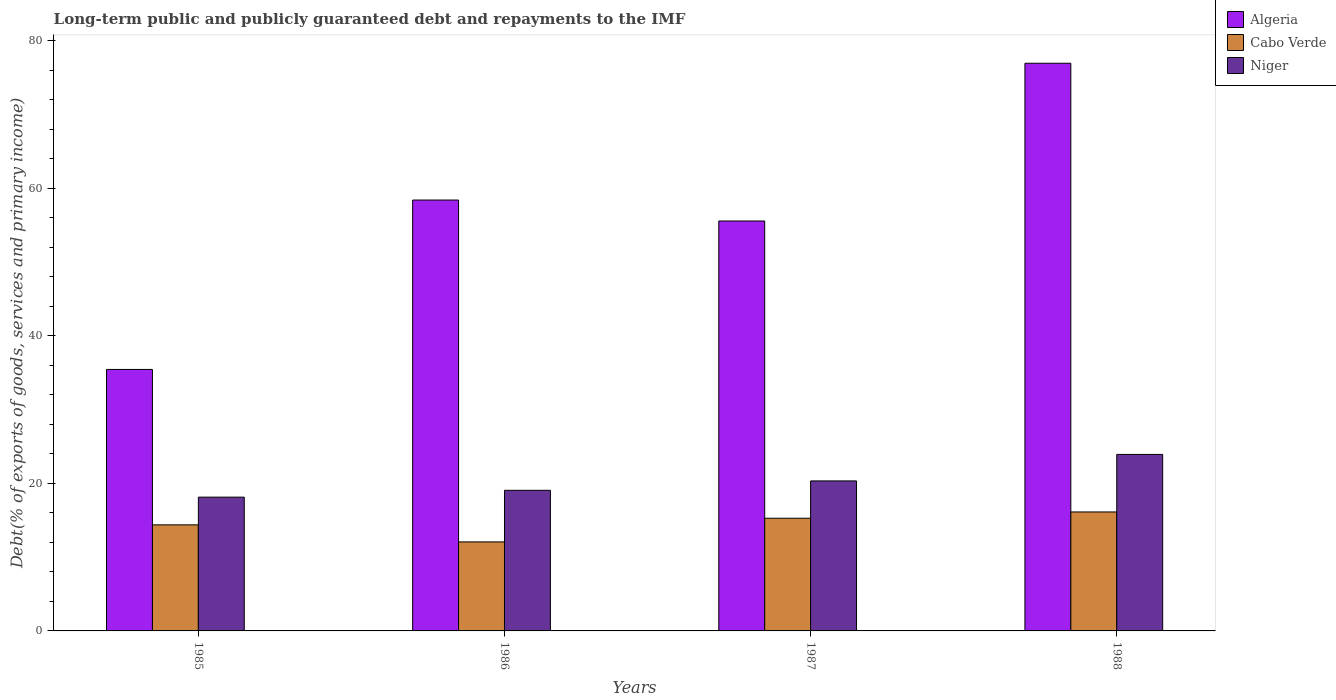Are the number of bars per tick equal to the number of legend labels?
Your answer should be very brief. Yes. Are the number of bars on each tick of the X-axis equal?
Offer a very short reply. Yes. What is the debt and repayments in Niger in 1986?
Ensure brevity in your answer.  19.05. Across all years, what is the maximum debt and repayments in Algeria?
Ensure brevity in your answer.  76.93. Across all years, what is the minimum debt and repayments in Algeria?
Your answer should be very brief. 35.43. In which year was the debt and repayments in Algeria maximum?
Your response must be concise. 1988. In which year was the debt and repayments in Cabo Verde minimum?
Provide a succinct answer. 1986. What is the total debt and repayments in Algeria in the graph?
Provide a succinct answer. 226.31. What is the difference between the debt and repayments in Niger in 1987 and that in 1988?
Your response must be concise. -3.59. What is the difference between the debt and repayments in Cabo Verde in 1986 and the debt and repayments in Niger in 1987?
Ensure brevity in your answer.  -8.27. What is the average debt and repayments in Algeria per year?
Offer a terse response. 56.58. In the year 1986, what is the difference between the debt and repayments in Cabo Verde and debt and repayments in Niger?
Your response must be concise. -6.99. In how many years, is the debt and repayments in Cabo Verde greater than 68 %?
Provide a short and direct response. 0. What is the ratio of the debt and repayments in Algeria in 1985 to that in 1986?
Your response must be concise. 0.61. Is the debt and repayments in Niger in 1986 less than that in 1987?
Ensure brevity in your answer.  Yes. Is the difference between the debt and repayments in Cabo Verde in 1986 and 1987 greater than the difference between the debt and repayments in Niger in 1986 and 1987?
Offer a terse response. No. What is the difference between the highest and the second highest debt and repayments in Niger?
Provide a succinct answer. 3.59. What is the difference between the highest and the lowest debt and repayments in Algeria?
Provide a succinct answer. 41.49. Is the sum of the debt and repayments in Algeria in 1985 and 1987 greater than the maximum debt and repayments in Cabo Verde across all years?
Your response must be concise. Yes. What does the 1st bar from the left in 1985 represents?
Give a very brief answer. Algeria. What does the 1st bar from the right in 1986 represents?
Provide a short and direct response. Niger. Are all the bars in the graph horizontal?
Ensure brevity in your answer.  No. Are the values on the major ticks of Y-axis written in scientific E-notation?
Provide a succinct answer. No. Does the graph contain grids?
Provide a succinct answer. No. How many legend labels are there?
Make the answer very short. 3. How are the legend labels stacked?
Ensure brevity in your answer.  Vertical. What is the title of the graph?
Make the answer very short. Long-term public and publicly guaranteed debt and repayments to the IMF. Does "Zambia" appear as one of the legend labels in the graph?
Provide a short and direct response. No. What is the label or title of the Y-axis?
Offer a terse response. Debt(% of exports of goods, services and primary income). What is the Debt(% of exports of goods, services and primary income) of Algeria in 1985?
Offer a very short reply. 35.43. What is the Debt(% of exports of goods, services and primary income) of Cabo Verde in 1985?
Offer a terse response. 14.37. What is the Debt(% of exports of goods, services and primary income) in Niger in 1985?
Give a very brief answer. 18.13. What is the Debt(% of exports of goods, services and primary income) of Algeria in 1986?
Provide a short and direct response. 58.39. What is the Debt(% of exports of goods, services and primary income) in Cabo Verde in 1986?
Give a very brief answer. 12.06. What is the Debt(% of exports of goods, services and primary income) of Niger in 1986?
Keep it short and to the point. 19.05. What is the Debt(% of exports of goods, services and primary income) of Algeria in 1987?
Give a very brief answer. 55.55. What is the Debt(% of exports of goods, services and primary income) in Cabo Verde in 1987?
Your answer should be compact. 15.27. What is the Debt(% of exports of goods, services and primary income) of Niger in 1987?
Your answer should be very brief. 20.33. What is the Debt(% of exports of goods, services and primary income) of Algeria in 1988?
Make the answer very short. 76.93. What is the Debt(% of exports of goods, services and primary income) in Cabo Verde in 1988?
Offer a very short reply. 16.12. What is the Debt(% of exports of goods, services and primary income) in Niger in 1988?
Your response must be concise. 23.92. Across all years, what is the maximum Debt(% of exports of goods, services and primary income) in Algeria?
Offer a terse response. 76.93. Across all years, what is the maximum Debt(% of exports of goods, services and primary income) in Cabo Verde?
Ensure brevity in your answer.  16.12. Across all years, what is the maximum Debt(% of exports of goods, services and primary income) of Niger?
Make the answer very short. 23.92. Across all years, what is the minimum Debt(% of exports of goods, services and primary income) of Algeria?
Ensure brevity in your answer.  35.43. Across all years, what is the minimum Debt(% of exports of goods, services and primary income) of Cabo Verde?
Your answer should be very brief. 12.06. Across all years, what is the minimum Debt(% of exports of goods, services and primary income) of Niger?
Keep it short and to the point. 18.13. What is the total Debt(% of exports of goods, services and primary income) in Algeria in the graph?
Your answer should be compact. 226.31. What is the total Debt(% of exports of goods, services and primary income) in Cabo Verde in the graph?
Make the answer very short. 57.83. What is the total Debt(% of exports of goods, services and primary income) in Niger in the graph?
Your response must be concise. 81.43. What is the difference between the Debt(% of exports of goods, services and primary income) of Algeria in 1985 and that in 1986?
Keep it short and to the point. -22.96. What is the difference between the Debt(% of exports of goods, services and primary income) of Cabo Verde in 1985 and that in 1986?
Provide a short and direct response. 2.31. What is the difference between the Debt(% of exports of goods, services and primary income) in Niger in 1985 and that in 1986?
Make the answer very short. -0.93. What is the difference between the Debt(% of exports of goods, services and primary income) of Algeria in 1985 and that in 1987?
Offer a terse response. -20.12. What is the difference between the Debt(% of exports of goods, services and primary income) of Cabo Verde in 1985 and that in 1987?
Provide a succinct answer. -0.9. What is the difference between the Debt(% of exports of goods, services and primary income) of Niger in 1985 and that in 1987?
Give a very brief answer. -2.2. What is the difference between the Debt(% of exports of goods, services and primary income) of Algeria in 1985 and that in 1988?
Your answer should be compact. -41.49. What is the difference between the Debt(% of exports of goods, services and primary income) in Cabo Verde in 1985 and that in 1988?
Offer a terse response. -1.75. What is the difference between the Debt(% of exports of goods, services and primary income) of Niger in 1985 and that in 1988?
Keep it short and to the point. -5.79. What is the difference between the Debt(% of exports of goods, services and primary income) in Algeria in 1986 and that in 1987?
Keep it short and to the point. 2.84. What is the difference between the Debt(% of exports of goods, services and primary income) in Cabo Verde in 1986 and that in 1987?
Make the answer very short. -3.21. What is the difference between the Debt(% of exports of goods, services and primary income) in Niger in 1986 and that in 1987?
Offer a very short reply. -1.27. What is the difference between the Debt(% of exports of goods, services and primary income) of Algeria in 1986 and that in 1988?
Your answer should be compact. -18.54. What is the difference between the Debt(% of exports of goods, services and primary income) of Cabo Verde in 1986 and that in 1988?
Offer a terse response. -4.06. What is the difference between the Debt(% of exports of goods, services and primary income) in Niger in 1986 and that in 1988?
Offer a very short reply. -4.87. What is the difference between the Debt(% of exports of goods, services and primary income) of Algeria in 1987 and that in 1988?
Give a very brief answer. -21.37. What is the difference between the Debt(% of exports of goods, services and primary income) of Cabo Verde in 1987 and that in 1988?
Ensure brevity in your answer.  -0.85. What is the difference between the Debt(% of exports of goods, services and primary income) of Niger in 1987 and that in 1988?
Your answer should be very brief. -3.59. What is the difference between the Debt(% of exports of goods, services and primary income) of Algeria in 1985 and the Debt(% of exports of goods, services and primary income) of Cabo Verde in 1986?
Offer a very short reply. 23.37. What is the difference between the Debt(% of exports of goods, services and primary income) of Algeria in 1985 and the Debt(% of exports of goods, services and primary income) of Niger in 1986?
Offer a terse response. 16.38. What is the difference between the Debt(% of exports of goods, services and primary income) of Cabo Verde in 1985 and the Debt(% of exports of goods, services and primary income) of Niger in 1986?
Provide a succinct answer. -4.68. What is the difference between the Debt(% of exports of goods, services and primary income) of Algeria in 1985 and the Debt(% of exports of goods, services and primary income) of Cabo Verde in 1987?
Provide a succinct answer. 20.16. What is the difference between the Debt(% of exports of goods, services and primary income) in Algeria in 1985 and the Debt(% of exports of goods, services and primary income) in Niger in 1987?
Provide a succinct answer. 15.11. What is the difference between the Debt(% of exports of goods, services and primary income) of Cabo Verde in 1985 and the Debt(% of exports of goods, services and primary income) of Niger in 1987?
Offer a very short reply. -5.95. What is the difference between the Debt(% of exports of goods, services and primary income) in Algeria in 1985 and the Debt(% of exports of goods, services and primary income) in Cabo Verde in 1988?
Make the answer very short. 19.31. What is the difference between the Debt(% of exports of goods, services and primary income) of Algeria in 1985 and the Debt(% of exports of goods, services and primary income) of Niger in 1988?
Give a very brief answer. 11.51. What is the difference between the Debt(% of exports of goods, services and primary income) in Cabo Verde in 1985 and the Debt(% of exports of goods, services and primary income) in Niger in 1988?
Offer a very short reply. -9.55. What is the difference between the Debt(% of exports of goods, services and primary income) in Algeria in 1986 and the Debt(% of exports of goods, services and primary income) in Cabo Verde in 1987?
Offer a terse response. 43.12. What is the difference between the Debt(% of exports of goods, services and primary income) of Algeria in 1986 and the Debt(% of exports of goods, services and primary income) of Niger in 1987?
Give a very brief answer. 38.06. What is the difference between the Debt(% of exports of goods, services and primary income) in Cabo Verde in 1986 and the Debt(% of exports of goods, services and primary income) in Niger in 1987?
Offer a terse response. -8.27. What is the difference between the Debt(% of exports of goods, services and primary income) in Algeria in 1986 and the Debt(% of exports of goods, services and primary income) in Cabo Verde in 1988?
Give a very brief answer. 42.27. What is the difference between the Debt(% of exports of goods, services and primary income) of Algeria in 1986 and the Debt(% of exports of goods, services and primary income) of Niger in 1988?
Offer a very short reply. 34.47. What is the difference between the Debt(% of exports of goods, services and primary income) in Cabo Verde in 1986 and the Debt(% of exports of goods, services and primary income) in Niger in 1988?
Your answer should be compact. -11.86. What is the difference between the Debt(% of exports of goods, services and primary income) of Algeria in 1987 and the Debt(% of exports of goods, services and primary income) of Cabo Verde in 1988?
Provide a succinct answer. 39.43. What is the difference between the Debt(% of exports of goods, services and primary income) in Algeria in 1987 and the Debt(% of exports of goods, services and primary income) in Niger in 1988?
Make the answer very short. 31.63. What is the difference between the Debt(% of exports of goods, services and primary income) of Cabo Verde in 1987 and the Debt(% of exports of goods, services and primary income) of Niger in 1988?
Provide a short and direct response. -8.65. What is the average Debt(% of exports of goods, services and primary income) in Algeria per year?
Your answer should be very brief. 56.58. What is the average Debt(% of exports of goods, services and primary income) in Cabo Verde per year?
Make the answer very short. 14.46. What is the average Debt(% of exports of goods, services and primary income) in Niger per year?
Your answer should be very brief. 20.36. In the year 1985, what is the difference between the Debt(% of exports of goods, services and primary income) in Algeria and Debt(% of exports of goods, services and primary income) in Cabo Verde?
Your answer should be compact. 21.06. In the year 1985, what is the difference between the Debt(% of exports of goods, services and primary income) in Algeria and Debt(% of exports of goods, services and primary income) in Niger?
Provide a short and direct response. 17.31. In the year 1985, what is the difference between the Debt(% of exports of goods, services and primary income) in Cabo Verde and Debt(% of exports of goods, services and primary income) in Niger?
Your answer should be very brief. -3.75. In the year 1986, what is the difference between the Debt(% of exports of goods, services and primary income) of Algeria and Debt(% of exports of goods, services and primary income) of Cabo Verde?
Keep it short and to the point. 46.33. In the year 1986, what is the difference between the Debt(% of exports of goods, services and primary income) in Algeria and Debt(% of exports of goods, services and primary income) in Niger?
Keep it short and to the point. 39.34. In the year 1986, what is the difference between the Debt(% of exports of goods, services and primary income) in Cabo Verde and Debt(% of exports of goods, services and primary income) in Niger?
Your response must be concise. -6.99. In the year 1987, what is the difference between the Debt(% of exports of goods, services and primary income) of Algeria and Debt(% of exports of goods, services and primary income) of Cabo Verde?
Your answer should be compact. 40.28. In the year 1987, what is the difference between the Debt(% of exports of goods, services and primary income) of Algeria and Debt(% of exports of goods, services and primary income) of Niger?
Ensure brevity in your answer.  35.22. In the year 1987, what is the difference between the Debt(% of exports of goods, services and primary income) of Cabo Verde and Debt(% of exports of goods, services and primary income) of Niger?
Provide a short and direct response. -5.06. In the year 1988, what is the difference between the Debt(% of exports of goods, services and primary income) of Algeria and Debt(% of exports of goods, services and primary income) of Cabo Verde?
Ensure brevity in your answer.  60.81. In the year 1988, what is the difference between the Debt(% of exports of goods, services and primary income) of Algeria and Debt(% of exports of goods, services and primary income) of Niger?
Give a very brief answer. 53.01. In the year 1988, what is the difference between the Debt(% of exports of goods, services and primary income) of Cabo Verde and Debt(% of exports of goods, services and primary income) of Niger?
Provide a short and direct response. -7.8. What is the ratio of the Debt(% of exports of goods, services and primary income) of Algeria in 1985 to that in 1986?
Give a very brief answer. 0.61. What is the ratio of the Debt(% of exports of goods, services and primary income) of Cabo Verde in 1985 to that in 1986?
Offer a terse response. 1.19. What is the ratio of the Debt(% of exports of goods, services and primary income) of Niger in 1985 to that in 1986?
Your answer should be very brief. 0.95. What is the ratio of the Debt(% of exports of goods, services and primary income) in Algeria in 1985 to that in 1987?
Keep it short and to the point. 0.64. What is the ratio of the Debt(% of exports of goods, services and primary income) in Cabo Verde in 1985 to that in 1987?
Provide a short and direct response. 0.94. What is the ratio of the Debt(% of exports of goods, services and primary income) of Niger in 1985 to that in 1987?
Provide a succinct answer. 0.89. What is the ratio of the Debt(% of exports of goods, services and primary income) of Algeria in 1985 to that in 1988?
Offer a very short reply. 0.46. What is the ratio of the Debt(% of exports of goods, services and primary income) of Cabo Verde in 1985 to that in 1988?
Your response must be concise. 0.89. What is the ratio of the Debt(% of exports of goods, services and primary income) of Niger in 1985 to that in 1988?
Provide a short and direct response. 0.76. What is the ratio of the Debt(% of exports of goods, services and primary income) in Algeria in 1986 to that in 1987?
Give a very brief answer. 1.05. What is the ratio of the Debt(% of exports of goods, services and primary income) in Cabo Verde in 1986 to that in 1987?
Make the answer very short. 0.79. What is the ratio of the Debt(% of exports of goods, services and primary income) in Niger in 1986 to that in 1987?
Provide a short and direct response. 0.94. What is the ratio of the Debt(% of exports of goods, services and primary income) of Algeria in 1986 to that in 1988?
Your response must be concise. 0.76. What is the ratio of the Debt(% of exports of goods, services and primary income) of Cabo Verde in 1986 to that in 1988?
Ensure brevity in your answer.  0.75. What is the ratio of the Debt(% of exports of goods, services and primary income) in Niger in 1986 to that in 1988?
Provide a short and direct response. 0.8. What is the ratio of the Debt(% of exports of goods, services and primary income) in Algeria in 1987 to that in 1988?
Provide a succinct answer. 0.72. What is the ratio of the Debt(% of exports of goods, services and primary income) of Cabo Verde in 1987 to that in 1988?
Give a very brief answer. 0.95. What is the ratio of the Debt(% of exports of goods, services and primary income) in Niger in 1987 to that in 1988?
Give a very brief answer. 0.85. What is the difference between the highest and the second highest Debt(% of exports of goods, services and primary income) in Algeria?
Make the answer very short. 18.54. What is the difference between the highest and the second highest Debt(% of exports of goods, services and primary income) in Cabo Verde?
Give a very brief answer. 0.85. What is the difference between the highest and the second highest Debt(% of exports of goods, services and primary income) of Niger?
Provide a succinct answer. 3.59. What is the difference between the highest and the lowest Debt(% of exports of goods, services and primary income) in Algeria?
Ensure brevity in your answer.  41.49. What is the difference between the highest and the lowest Debt(% of exports of goods, services and primary income) in Cabo Verde?
Your response must be concise. 4.06. What is the difference between the highest and the lowest Debt(% of exports of goods, services and primary income) in Niger?
Provide a succinct answer. 5.79. 